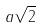<formula> <loc_0><loc_0><loc_500><loc_500>a \sqrt { 2 }</formula> 